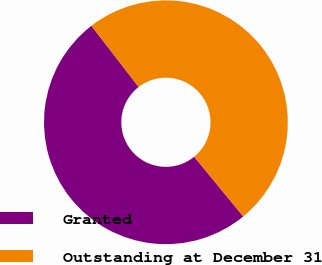Convert chart to OTSL. <chart><loc_0><loc_0><loc_500><loc_500><pie_chart><fcel>Granted<fcel>Outstanding at December 31<nl><fcel>50.48%<fcel>49.52%<nl></chart> 